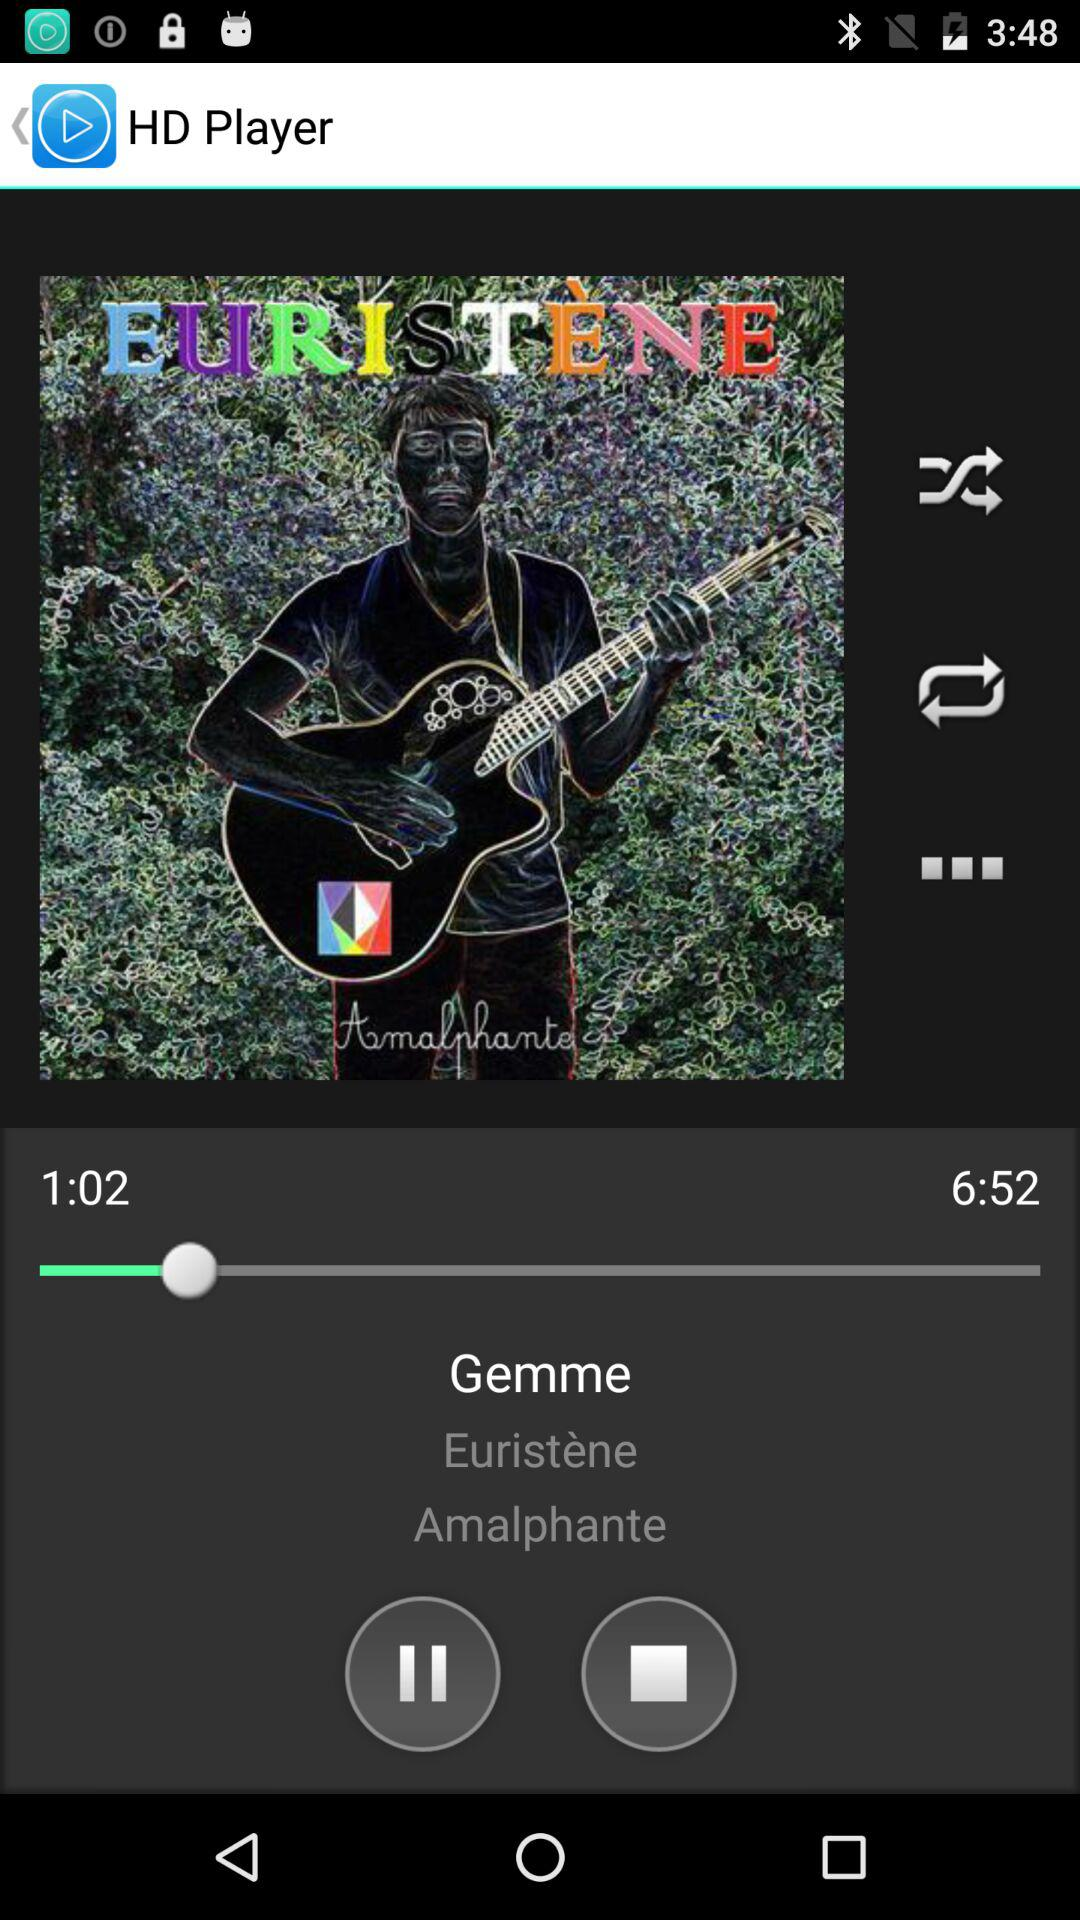What is the length of the song? The length of the song is 6:52. 